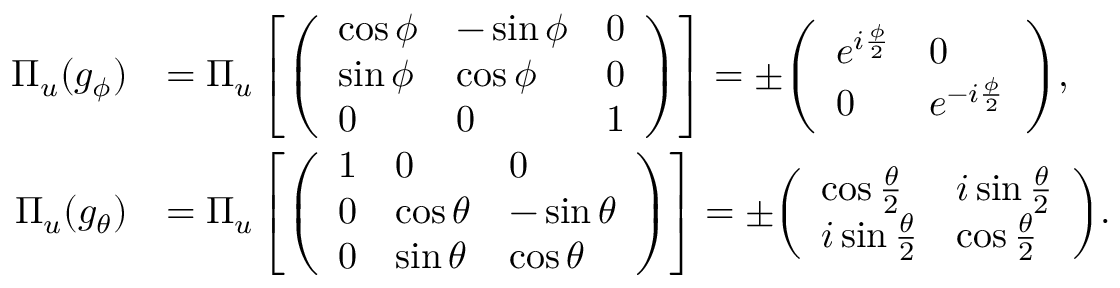<formula> <loc_0><loc_0><loc_500><loc_500>{ \begin{array} { r l } { \Pi _ { u } ( g _ { \phi } ) } & { = \Pi _ { u } \left [ { \left ( \begin{array} { l l l } { \cos \phi } & { - \sin \phi } & { 0 } \\ { \sin \phi } & { \cos \phi } & { 0 } \\ { 0 } & { 0 } & { 1 } \end{array} \right ) } \right ] = \pm { \left ( \begin{array} { l l } { e ^ { i { \frac { \phi } { 2 } } } } & { 0 } \\ { 0 } & { e ^ { - i { \frac { \phi } { 2 } } } } \end{array} \right ) } , } \\ { \Pi _ { u } ( g _ { \theta } ) } & { = \Pi _ { u } \left [ { \left ( \begin{array} { l l l } { 1 } & { 0 } & { 0 } \\ { 0 } & { \cos \theta } & { - \sin \theta } \\ { 0 } & { \sin \theta } & { \cos \theta } \end{array} \right ) } \right ] = \pm { \left ( \begin{array} { l l } { \cos { \frac { \theta } { 2 } } } & { i \sin { \frac { \theta } { 2 } } } \\ { i \sin { \frac { \theta } { 2 } } } & { \cos { \frac { \theta } { 2 } } } \end{array} \right ) } . } \end{array} }</formula> 